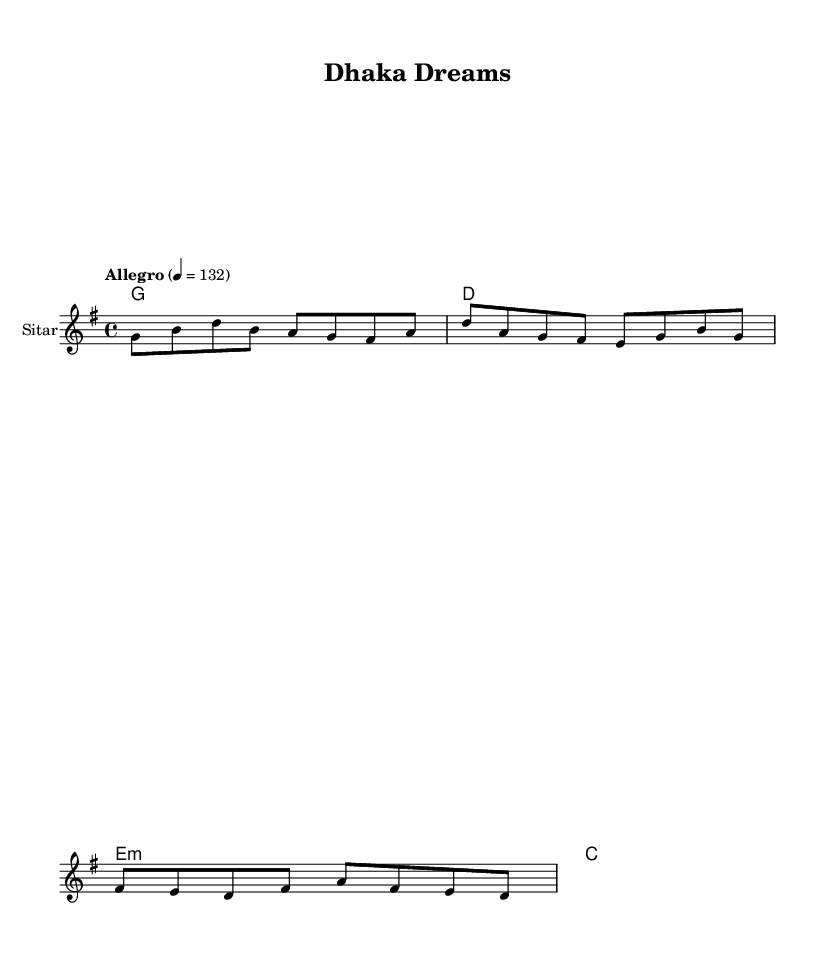What is the key signature of this music? The key signature is indicated at the beginning of the score. In this case, the notation shows one sharp, which corresponds to G major.
Answer: G major What is the time signature of this piece? The time signature is shown at the beginning of the score, displaying '4/4', indicating there are four beats in each measure.
Answer: 4/4 What is the tempo marking for the music? The tempo marking is provided in the score as 'Allegro', along with a metronome marking of 132 beats per minute.
Answer: Allegro What instrument is the melody written for? The instrument name is mentioned in the score as 'Sitar', indicating that the melody is specifically composed for this instrument.
Answer: Sitar How many measures are in the melody? By counting the number of segments in the melody provided, it comprises a total of four measures, each separated by a bar line.
Answer: 4 What is the theme of the lyrics? The lyrics focus on urban development, celebrating Dhaka's growth with references to metro lines and skyscrapers, indicating a modern urban theme.
Answer: Urban development What type of chord is used in the third measure of harmonies? The chord is indicated as 'e:m' in the score, representing an 'E minor' chord, which contributes to the tonal quality of the music.
Answer: E minor 